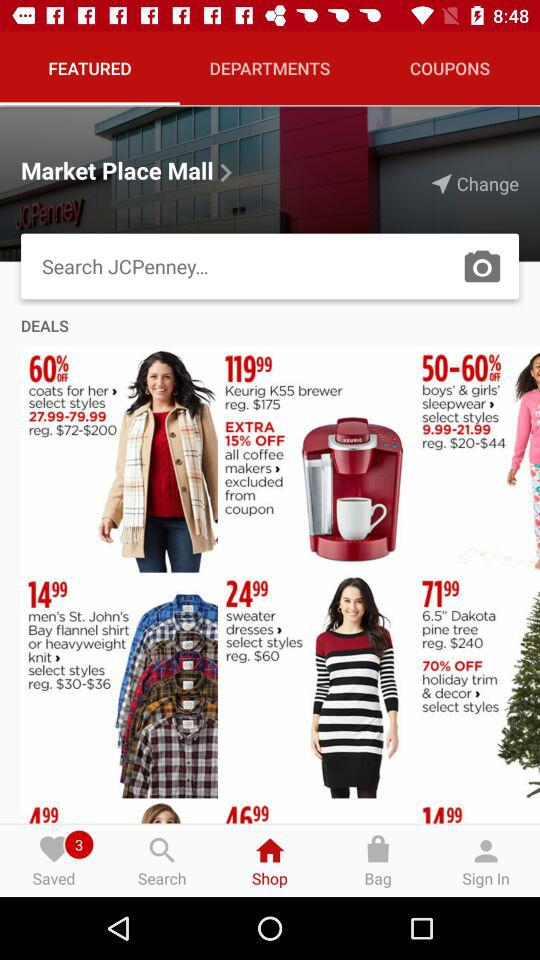What is the price of sweater dresses? The price is 24.99. 